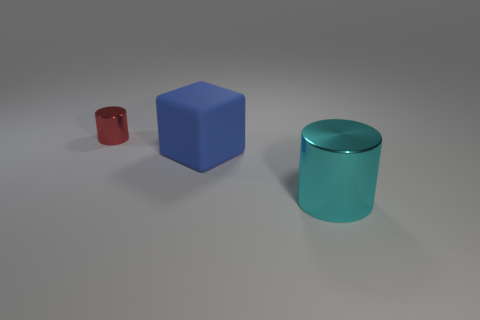Add 2 green shiny blocks. How many objects exist? 5 Subtract all cubes. How many objects are left? 2 Add 3 big brown rubber objects. How many big brown rubber objects exist? 3 Subtract 0 gray cubes. How many objects are left? 3 Subtract all big red shiny balls. Subtract all big matte things. How many objects are left? 2 Add 2 large matte cubes. How many large matte cubes are left? 3 